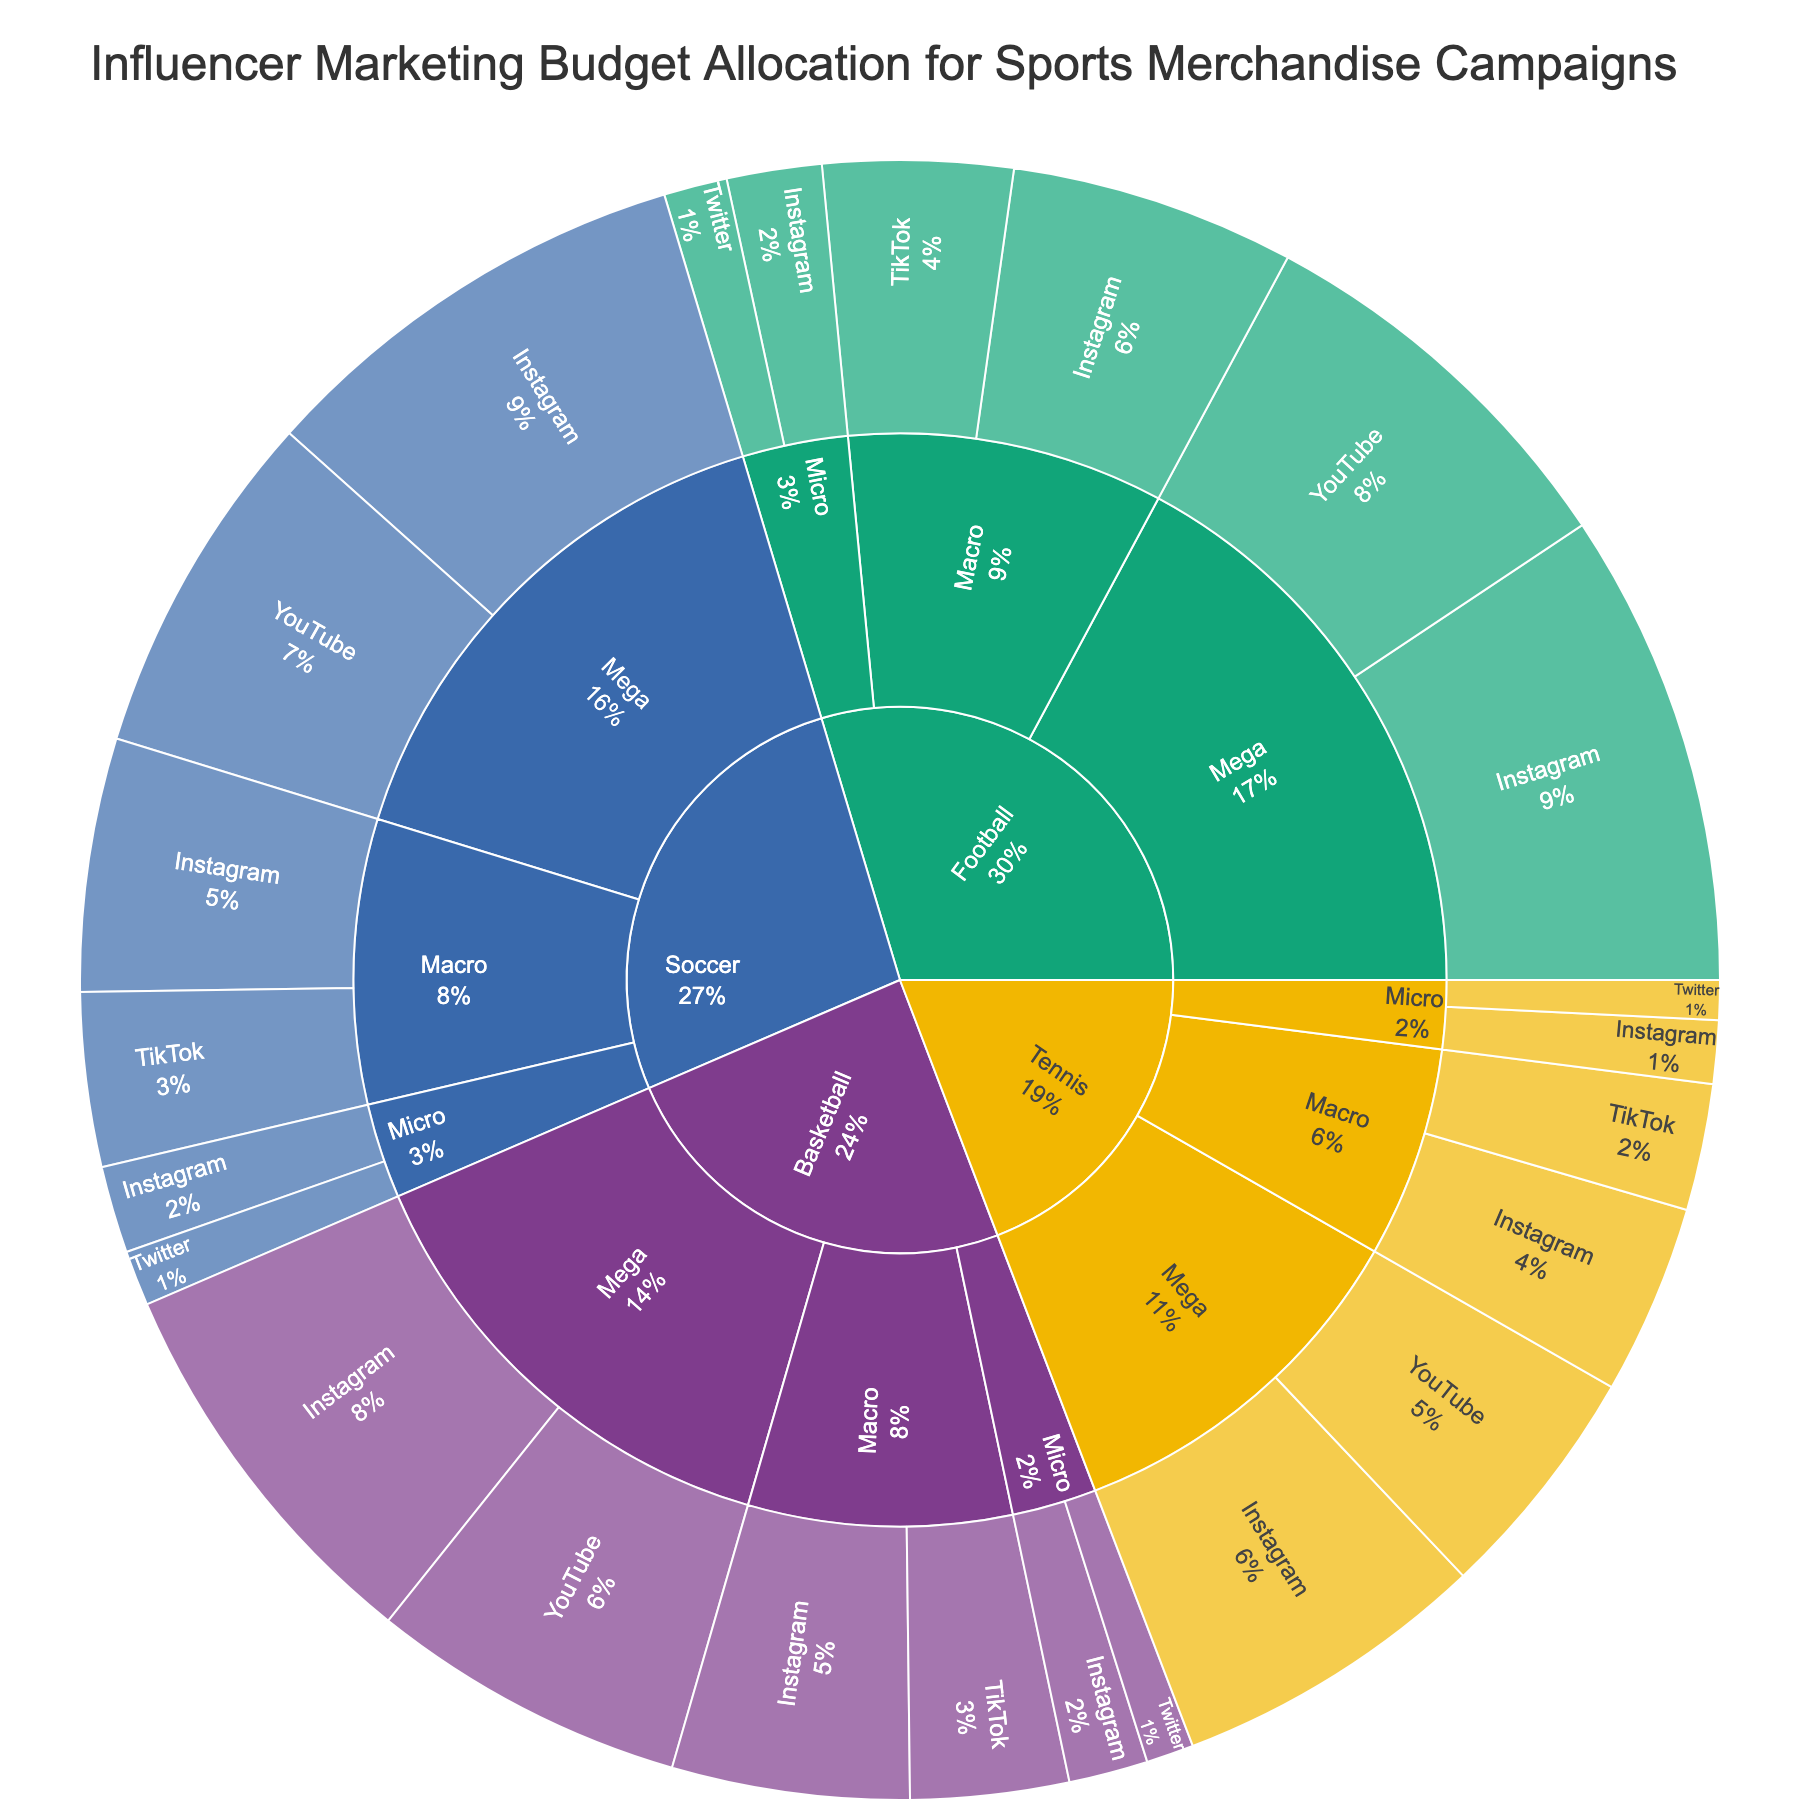What sport has the highest total budget? To find which sport has the highest total budget, we need to look at the outermost rings of the sunburst plot and compare the cumulative budgets for each sport.
Answer: Football What's the total budget allocated to Mega influencers across all sports? Look at each sport’s inner ring for Mega influencers and sum their budgets. Basketball ($250,000 + $200,000), Football ($300,000 + $250,000), Soccer ($280,000 + $220,000), and Tennis ($200,000 + $150,000). Total budget: $450,000 + $550,000 + $500,000 + $350,000 = $1,850,000
Answer: $1,850,000 Which platform has the least budget allocation under Micro influencers for Tennis? Under Tennis, navigate to the ring for Micro influencers and compare the budget allocations for each platform: Instagram ($40,000) and Twitter ($25,000). The platform with the least budget is Twitter.
Answer: Twitter How does the budget for Macro influencers on Instagram compare between Football and Soccer? First, check the budget allocation for Macro influencers on Instagram for both Football ($180,000) and Soccer ($160,000). Football has a higher budget compared to Soccer.
Answer: Football has a higher budget What percentage of the total budget is allocated to Instagram for Basketball? Navigate to Basketball and look for Instagram allocations. Sum the budgets for Mega, Macro, and Micro influencers on Instagram: $250,000 + $150,000 + $50,000 = $450,000. To find the percentage, sum all budgets for Basketball (Instagram + YouTube + TikTok + Twitter): $250,000 + $200,000 + $150,000 + $100,000 + $50,000 + $30,000 = $780,000. Calculate the percentage: ($450,000 / $780,000) * 100 ≈ 57.69%.
Answer: 57.69% Which influencer tier has the highest budget allocation on TikTok for all sports combined? Summarize TikTok budgets for Mega, Macro, and Micro influencers across each sport. Compare the totals: Mega ($0), Macro ($100,000 + $120,000 + $110,000 + $80,000), and Micro ($0). Macro has a total of $410,000 for all sports.
Answer: Macro If you combine the budgets of Micro influencers on Twitter across all sports, what is the total? Add the Micro influencer budgets on Twitter for Basketball ($30,000), Football ($40,000), Soccer ($35,000), and Tennis ($25,000). The total is $30,000 + $40,000 + $35,000 + $25,000 = $130,000.
Answer: $130,000 What sport allocates more of its budget to YouTube for Mega influencers, Football or Soccer? Compare budgets for YouTube under Mega influencers for Football ($250,000) and Soccer ($220,000). Football allocates more.
Answer: Football Which influencer tier receives the highest budget allocation for Instagram in Soccer? Check the budgets for Mega ($280,000), Macro ($160,000), and Micro ($55,000) influencers on Instagram under Soccer. Mega influencers have the highest budget.
Answer: Mega Does TikTok or Twitter have a higher total budget for Macro influencers across all sports? Sum the budgets for Macro influencers on TikTok across all sports ($100,000 + $120,000 + $110,000 + $80,000) and Twitter ($0). TikTok has a higher total budget with $410,000 compared to Twitter, which has $0.
Answer: TikTok 